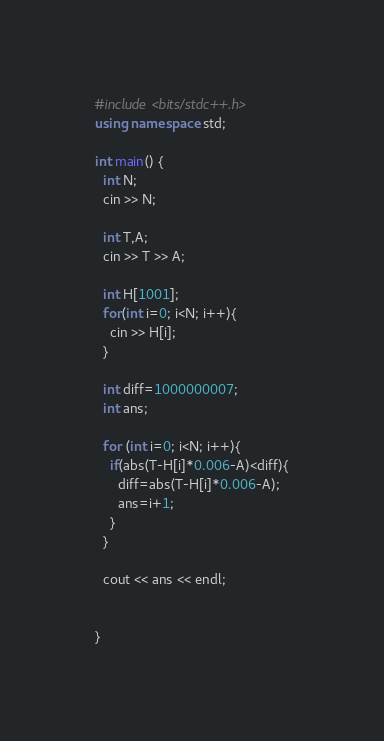<code> <loc_0><loc_0><loc_500><loc_500><_C++_>#include <bits/stdc++.h>
using namespace std;

int main() {
  int N;
  cin >> N;
  
  int T,A;
  cin >> T >> A;
  
  int H[1001];
  for(int i=0; i<N; i++){
    cin >> H[i];
  }
  
  int diff=1000000007;
  int ans;
  
  for (int i=0; i<N; i++){
    if(abs(T-H[i]*0.006-A)<diff){
      diff=abs(T-H[i]*0.006-A);
      ans=i+1;
    }
  }
  
  cout << ans << endl;
  
  
}</code> 